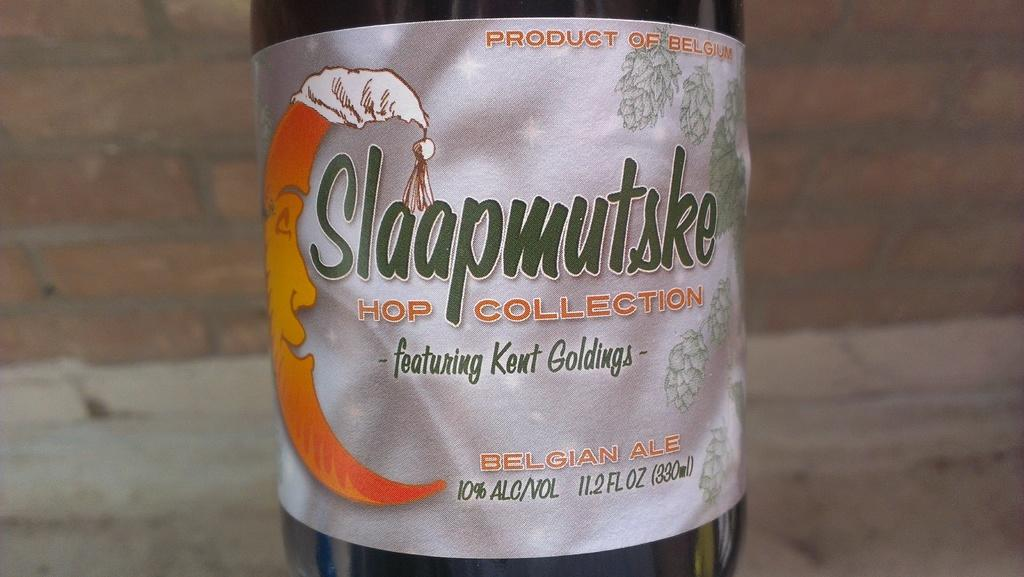<image>
Describe the image concisely. Label with a mmon and has green lettering stating Slaapmutske Hop Collection. 